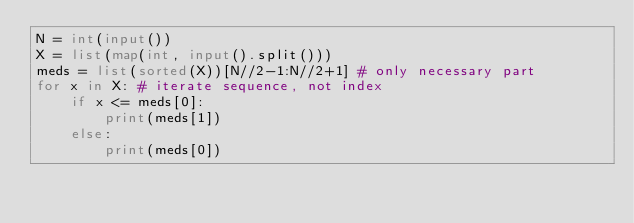<code> <loc_0><loc_0><loc_500><loc_500><_Python_>N = int(input())
X = list(map(int, input().split()))
meds = list(sorted(X))[N//2-1:N//2+1] # only necessary part
for x in X: # iterate sequence, not index
    if x <= meds[0]:
        print(meds[1])
    else:
        print(meds[0])
</code> 